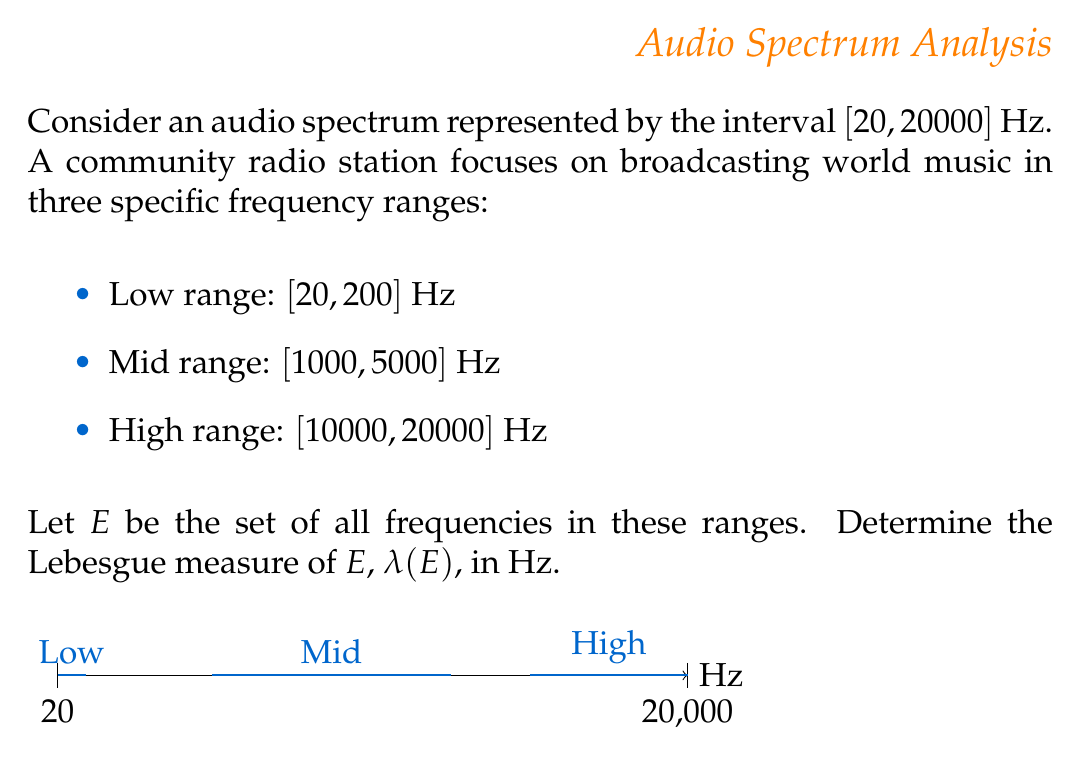Can you answer this question? To find the Lebesgue measure of set $E$, we need to sum up the measures of the three disjoint intervals:

1. Low range: $\lambda([20, 200]) = 200 - 20 = 180$ Hz
2. Mid range: $\lambda([1000, 5000]) = 5000 - 1000 = 4000$ Hz
3. High range: $\lambda([10000, 20000]) = 20000 - 10000 = 10000$ Hz

The Lebesgue measure of a set on the real line is equivalent to the sum of the lengths of its constituent intervals. Since these ranges are disjoint, we can simply add their individual measures:

$$\lambda(E) = \lambda([20, 200]) + \lambda([1000, 5000]) + \lambda([10000, 20000])$$
$$\lambda(E) = 180 + 4000 + 10000 = 14180\text{ Hz}$$

This result represents the total frequency range covered by the community radio station's world music broadcasts across the three specified ranges.
Answer: $14180\text{ Hz}$ 